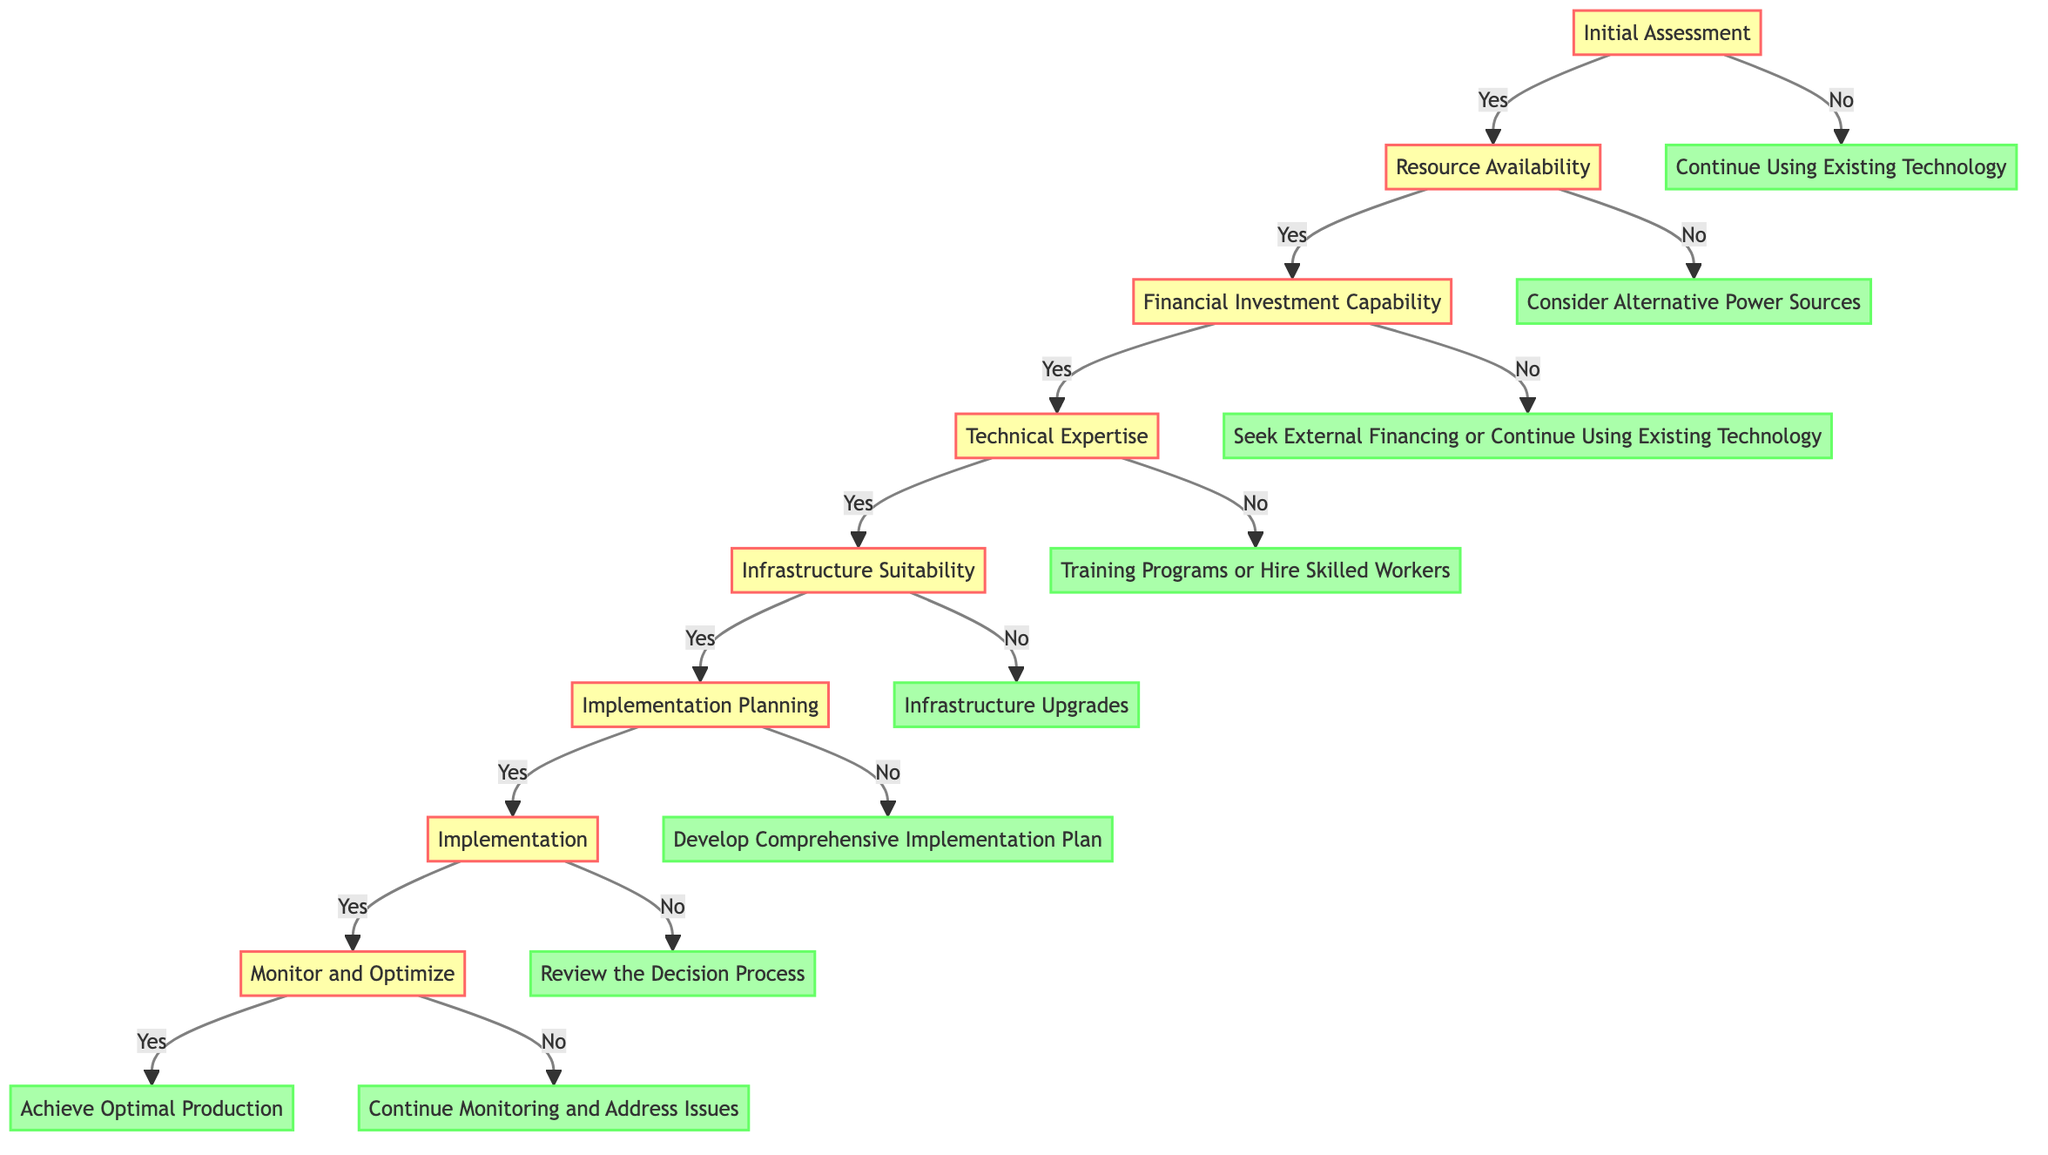What is the first decision point in the diagram? The first decision point in the diagram is "Initial Assessment". It is the starting node where the decision-making process begins.
Answer: Initial Assessment How many total nodes are in the decision tree? Counting all the decision points and endpoints in the diagram, there are 12 total nodes. This includes decision nodes and endpoint nodes.
Answer: 12 What question is asked at the "Technical Expertise" node? The question asked at the "Technical Expertise" node is "Does the workforce have the necessary technical skills?" It assesses the capability of the workforce to adopt steam power.
Answer: Does the workforce have the necessary technical skills? If the answer to "Resource Availability" is "No", what is the next step? If the answer to "Resource Availability" is "No", the next step is "Consider Alternative Power Sources". This indicates a shift from steam power to other options.
Answer: Consider Alternative Power Sources What is the final step after "Monitor and Optimize" if the answer is "Yes"? If the answer to "Monitor and Optimize" is "Yes", the final step is "Achieve Optimal Production". This indicates successful optimization and efficiency in steam power usage.
Answer: Achieve Optimal Production If "Financial Investment Capability" is "No", what are the two options provided? If "Financial Investment Capability" is "No", the two options provided are "Seek External Financing" or "Continue Using Existing Technology". This shows the choices available when funds are insufficient for steam technology.
Answer: Seek External Financing or Continue Using Existing Technology What decision follows "Implementation Planning" if the answer is "No"? If the answer to "Implementation Planning" is "No", the decision that follows is "Develop Comprehensive Implementation Plan". This indicates the need for more careful planning before proceeding.
Answer: Develop Comprehensive Implementation Plan What node comes after "Implementation"? After "Implementation", the next node is "Monitor and Optimize". This step focuses on continual assessment of steam power usage for improvements.
Answer: Monitor and Optimize 